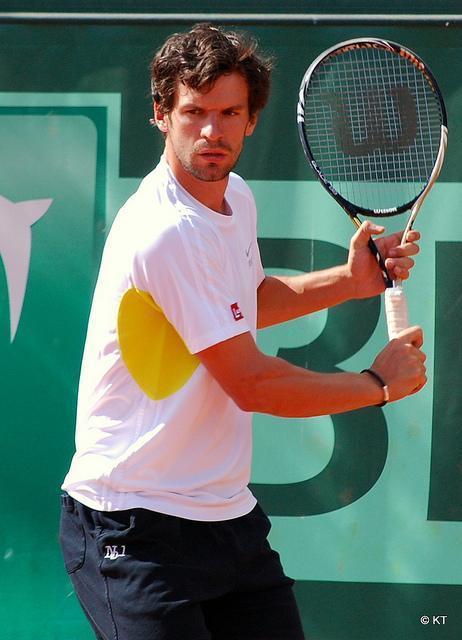How many cars are shown?
Give a very brief answer. 0. 